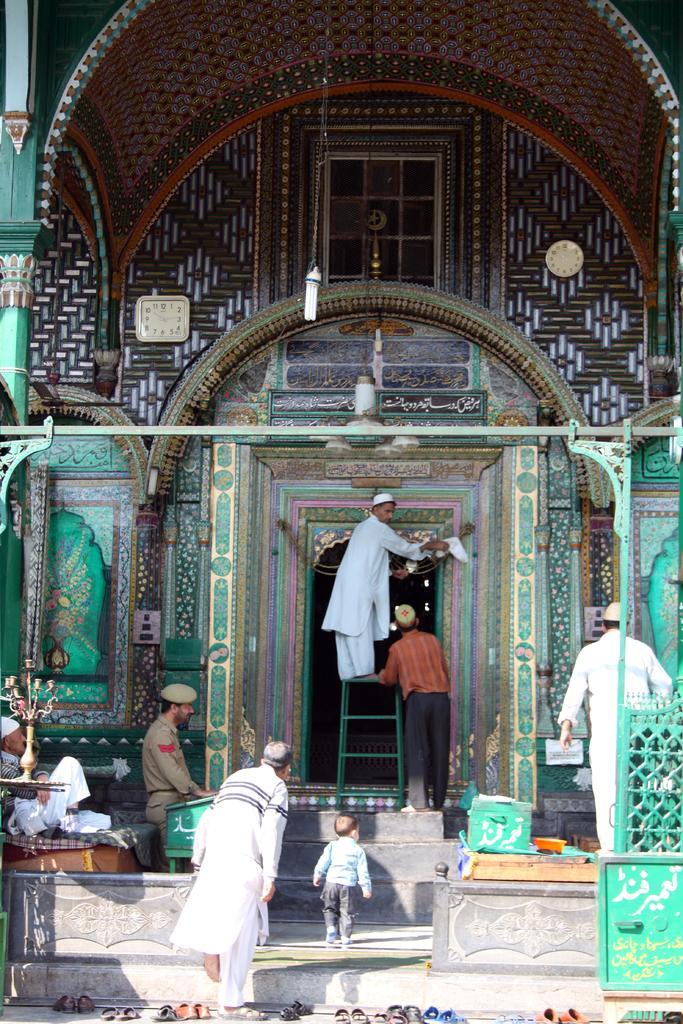Please provide a concise description of this image. In this picture we can see some people, ladder, building, clocks, foot wears and steps. 